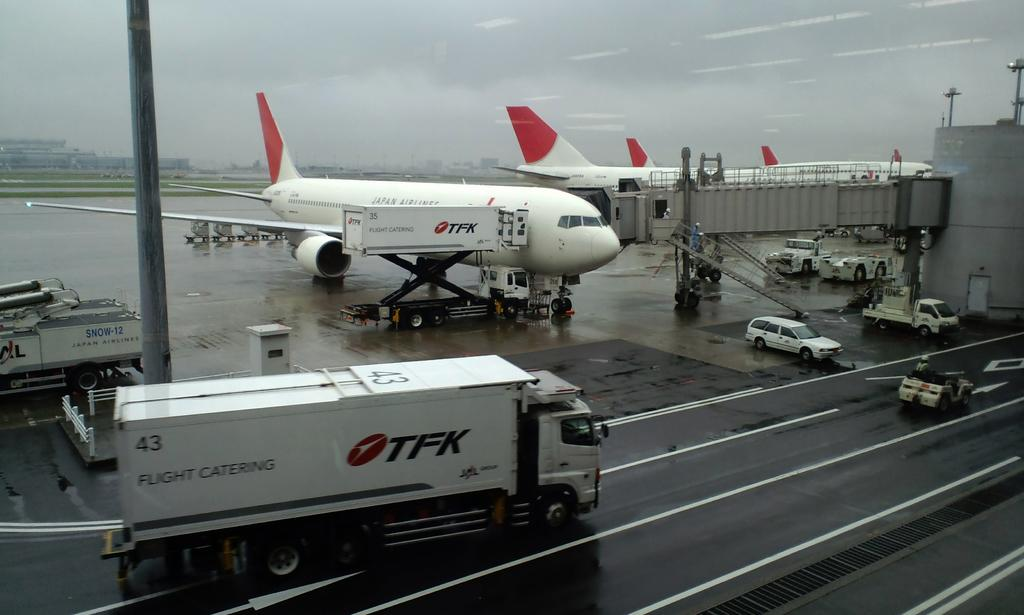Provide a one-sentence caption for the provided image. An airport landing with five planes from the airline TFK. 